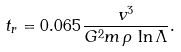<formula> <loc_0><loc_0><loc_500><loc_500>t _ { r } = 0 . 0 6 5 \, \frac { v ^ { 3 } } { G ^ { 2 } m \, \rho \, \ln \Lambda } .</formula> 